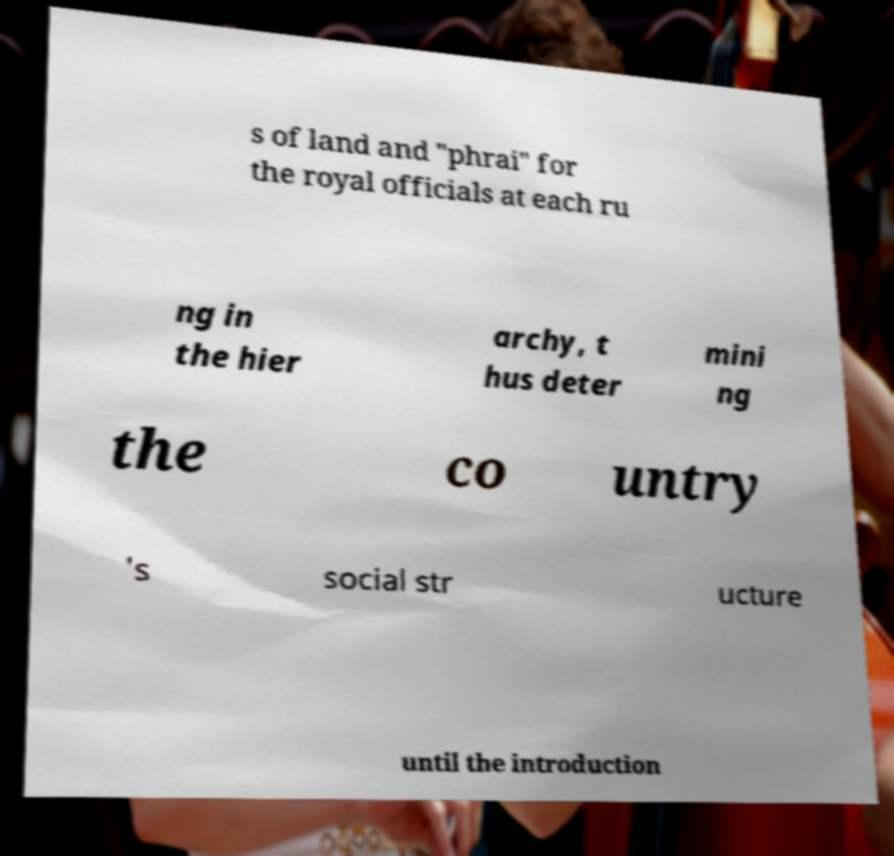Could you extract and type out the text from this image? s of land and "phrai" for the royal officials at each ru ng in the hier archy, t hus deter mini ng the co untry 's social str ucture until the introduction 